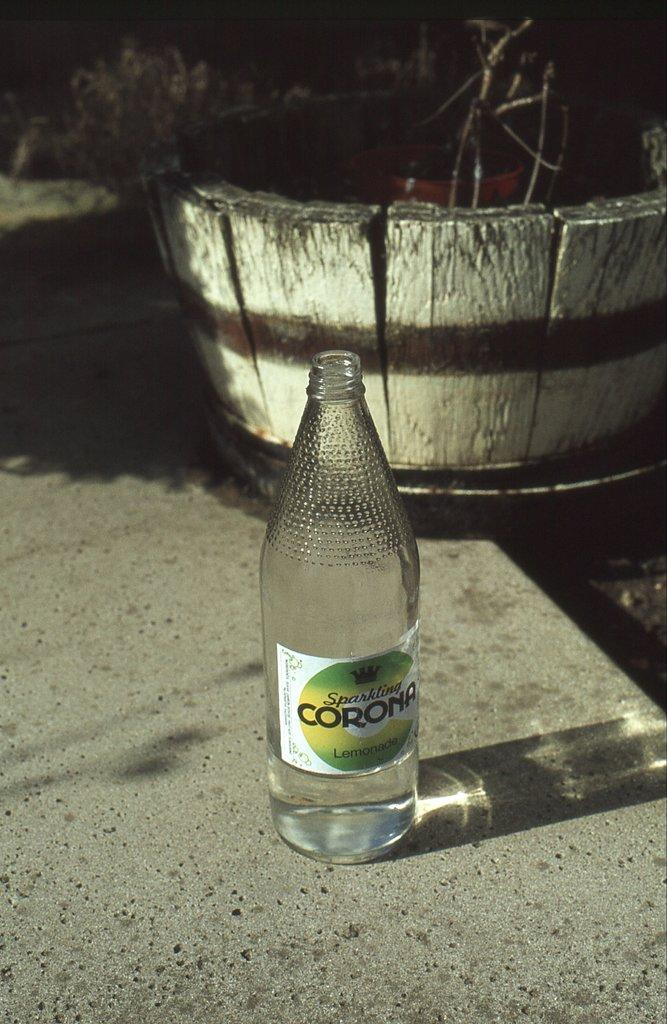<image>
Offer a succinct explanation of the picture presented. A bottle of sparkling Corona lemonade sitting outside on concrete. 